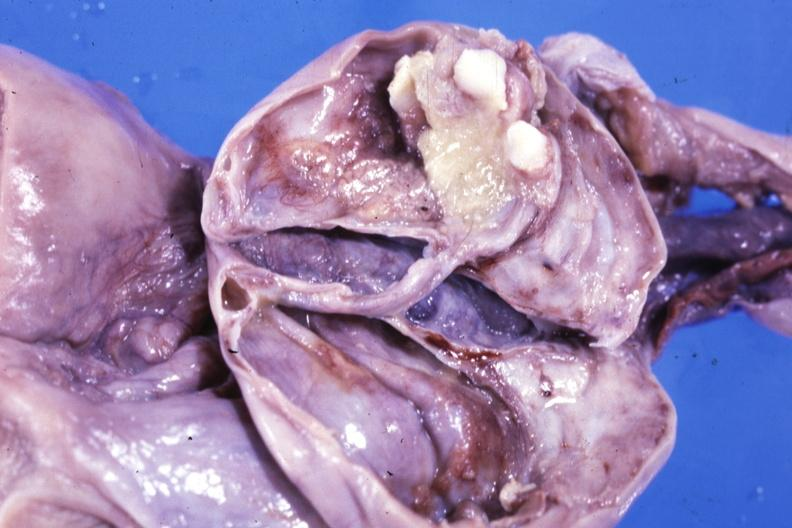what is present?
Answer the question using a single word or phrase. Benign cystic teratoma 